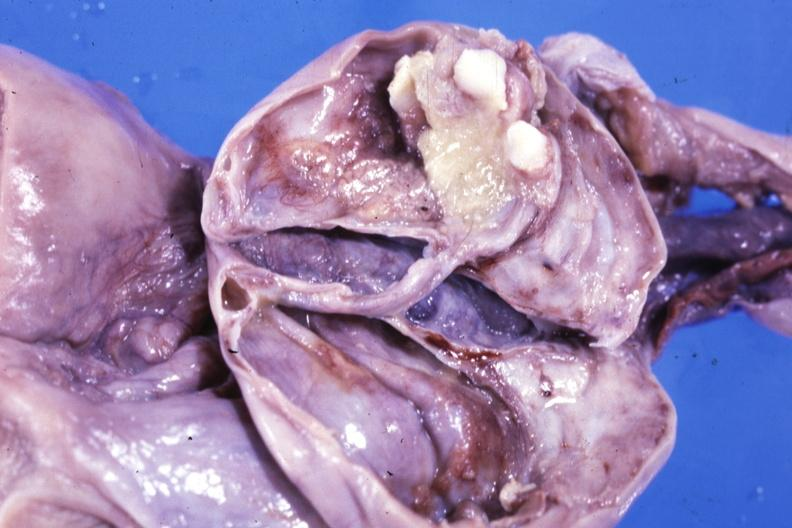what is present?
Answer the question using a single word or phrase. Benign cystic teratoma 